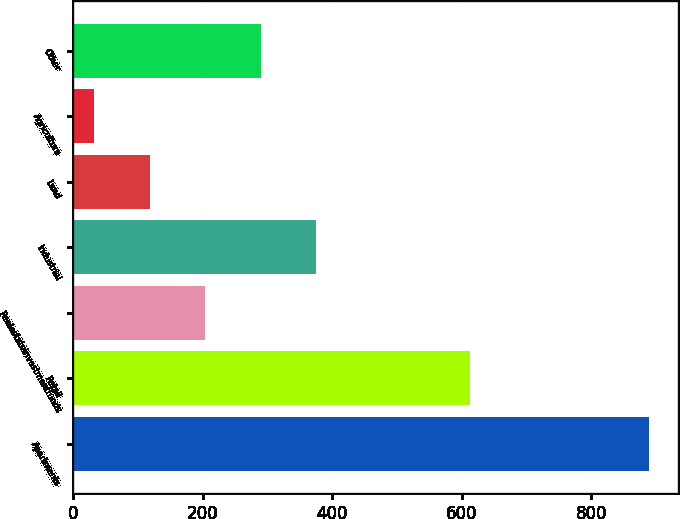Convert chart to OTSL. <chart><loc_0><loc_0><loc_500><loc_500><bar_chart><fcel>Apartments<fcel>Retail<fcel>Realestateinvestmentfunds<fcel>Industrial<fcel>Land<fcel>Agriculture<fcel>Other<nl><fcel>889<fcel>612<fcel>203.4<fcel>374.8<fcel>117.7<fcel>32<fcel>289.1<nl></chart> 